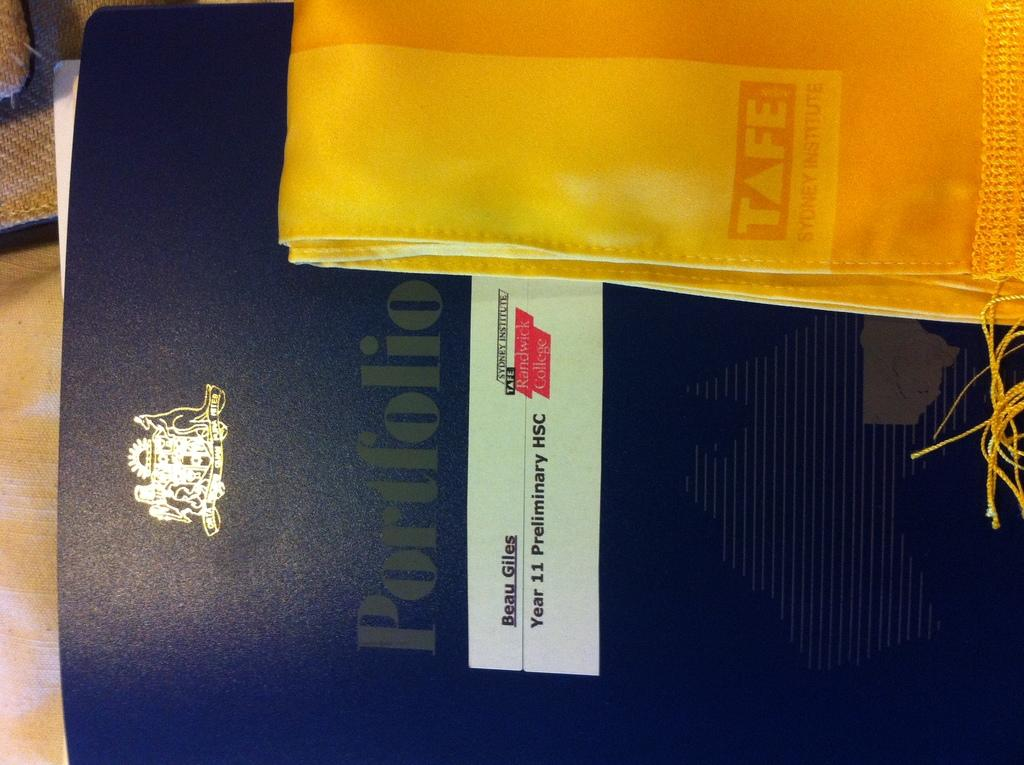<image>
Give a short and clear explanation of the subsequent image. A book cover that says Portfolio with the name Beau Giles on it. 